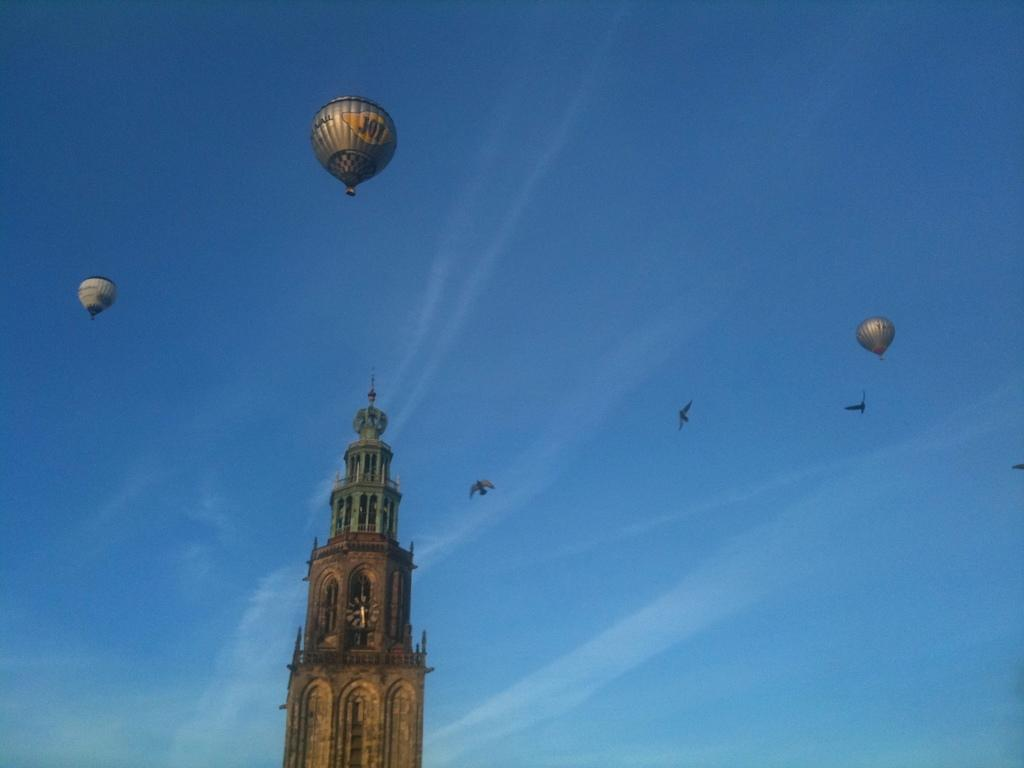What can be seen in the sky in the image? Birds are flying in the sky in the image. What objects are related to the sky in the image? There are parachutes in the image. What type of structure is present in the image? There is a clock tower in the image. Can you describe the clock tower's appearance in the image? The clock tower has walls and pillars. What type of cast can be seen on the parachutes in the image? There is no cast present on the parachutes in the image. What kind of doll is sitting on top of the clock tower in the image? There is no doll present on top of the clock tower in the image. 